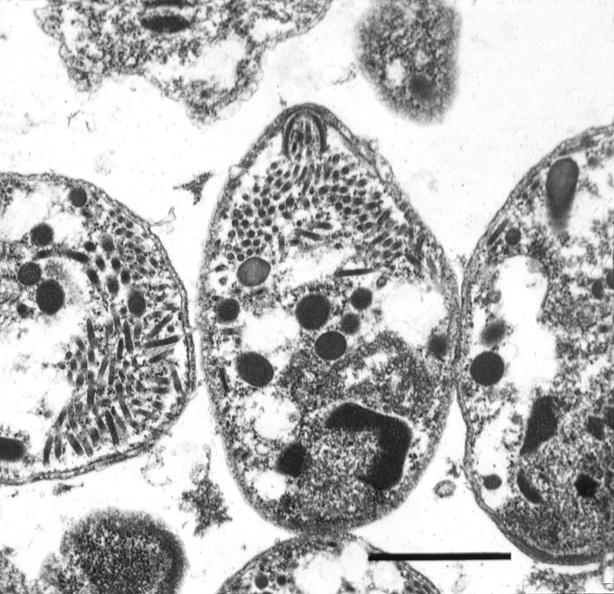s infiltrative process present?
Answer the question using a single word or phrase. No 